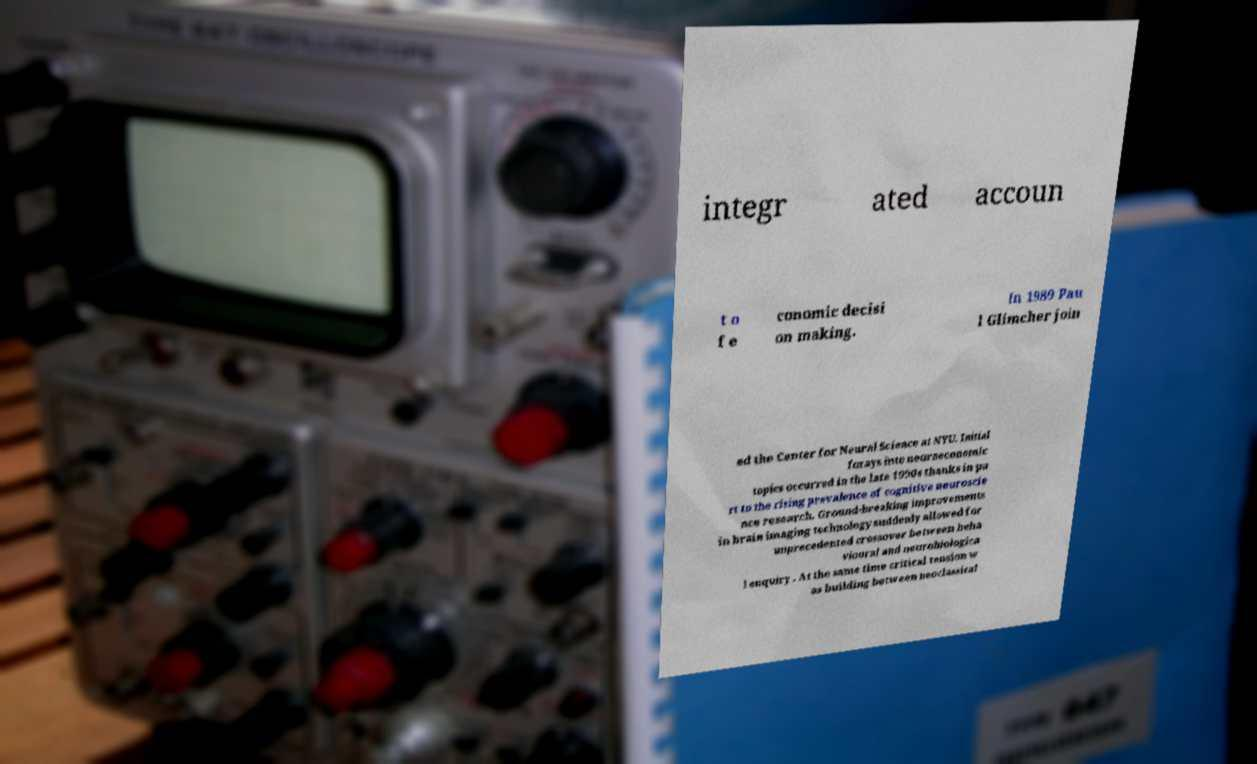Could you assist in decoding the text presented in this image and type it out clearly? integr ated accoun t o f e conomic decisi on making. In 1989 Pau l Glimcher join ed the Center for Neural Science at NYU. Initial forays into neuroeconomic topics occurred in the late 1990s thanks in pa rt to the rising prevalence of cognitive neuroscie nce research. Ground-breaking improvements in brain imaging technology suddenly allowed for unprecedented crossover between beha vioural and neurobiologica l enquiry . At the same time critical tension w as building between neoclassical 